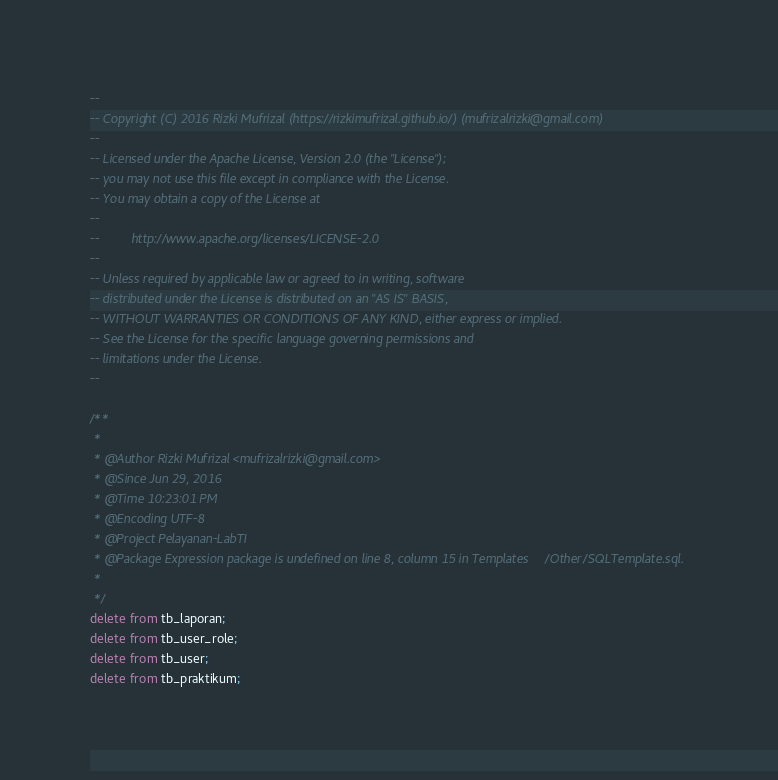<code> <loc_0><loc_0><loc_500><loc_500><_SQL_>--
-- Copyright (C) 2016 Rizki Mufrizal (https://rizkimufrizal.github.io/) (mufrizalrizki@gmail.com)
--
-- Licensed under the Apache License, Version 2.0 (the "License");
-- you may not use this file except in compliance with the License.
-- You may obtain a copy of the License at
--
--         http://www.apache.org/licenses/LICENSE-2.0
--
-- Unless required by applicable law or agreed to in writing, software
-- distributed under the License is distributed on an "AS IS" BASIS,
-- WITHOUT WARRANTIES OR CONDITIONS OF ANY KIND, either express or implied.
-- See the License for the specific language governing permissions and
-- limitations under the License.
--

/**
 *
 * @Author Rizki Mufrizal <mufrizalrizki@gmail.com>
 * @Since Jun 29, 2016
 * @Time 10:23:01 PM
 * @Encoding UTF-8
 * @Project Pelayanan-LabTI
 * @Package Expression package is undefined on line 8, column 15 in Templates/Other/SQLTemplate.sql.
 *
 */
delete from tb_laporan;
delete from tb_user_role;
delete from tb_user;
delete from tb_praktikum;</code> 